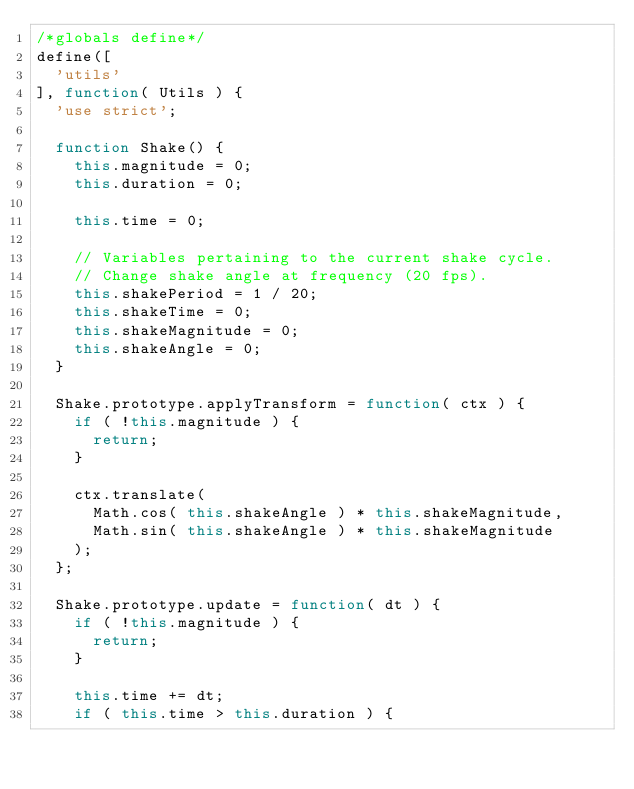Convert code to text. <code><loc_0><loc_0><loc_500><loc_500><_JavaScript_>/*globals define*/
define([
  'utils'
], function( Utils ) {
  'use strict';

  function Shake() {
    this.magnitude = 0;
    this.duration = 0;

    this.time = 0;

    // Variables pertaining to the current shake cycle.
    // Change shake angle at frequency (20 fps).
    this.shakePeriod = 1 / 20;
    this.shakeTime = 0;
    this.shakeMagnitude = 0;
    this.shakeAngle = 0;
  }

  Shake.prototype.applyTransform = function( ctx ) {
    if ( !this.magnitude ) {
      return;
    }

    ctx.translate(
      Math.cos( this.shakeAngle ) * this.shakeMagnitude,
      Math.sin( this.shakeAngle ) * this.shakeMagnitude
    );
  };

  Shake.prototype.update = function( dt ) {
    if ( !this.magnitude ) {
      return;
    }

    this.time += dt;
    if ( this.time > this.duration ) {</code> 